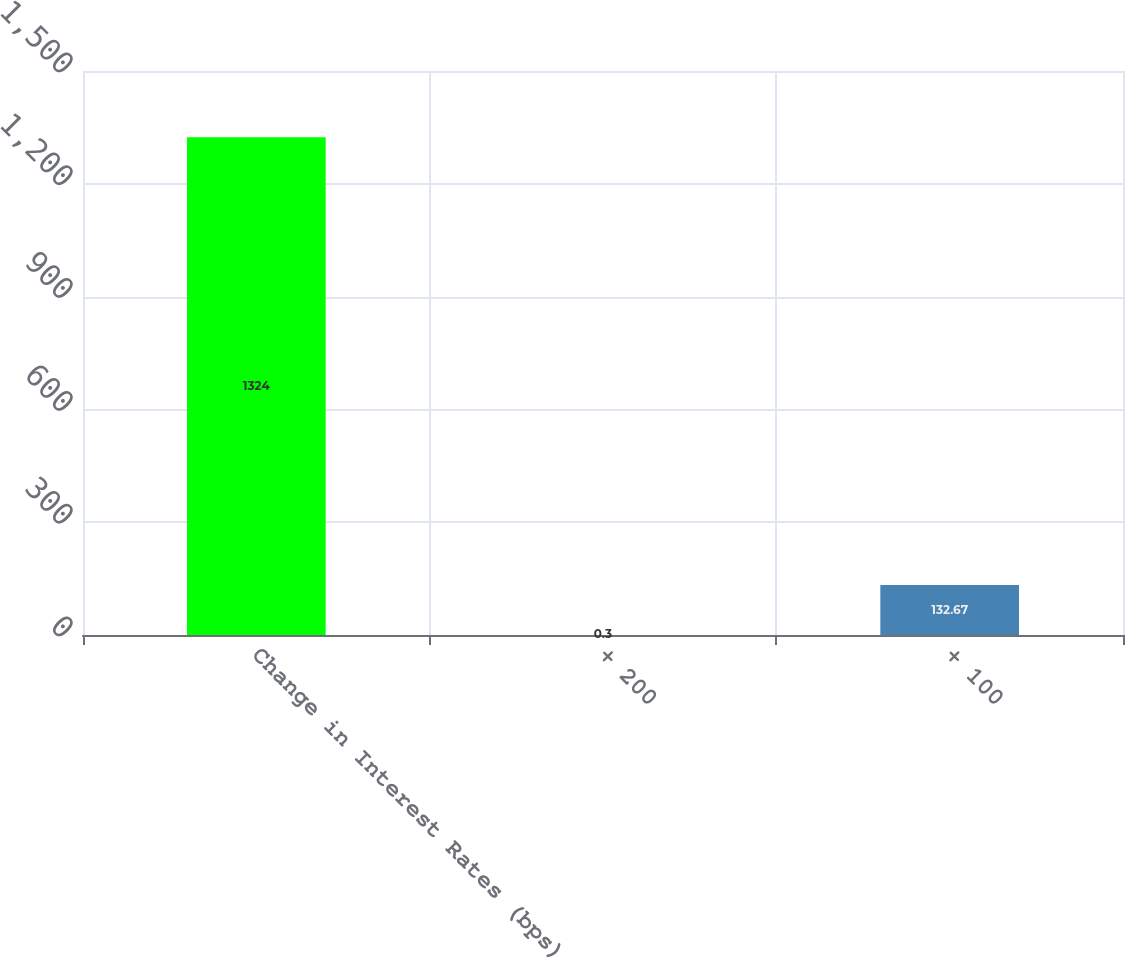Convert chart to OTSL. <chart><loc_0><loc_0><loc_500><loc_500><bar_chart><fcel>Change in Interest Rates (bps)<fcel>+ 200<fcel>+ 100<nl><fcel>1324<fcel>0.3<fcel>132.67<nl></chart> 